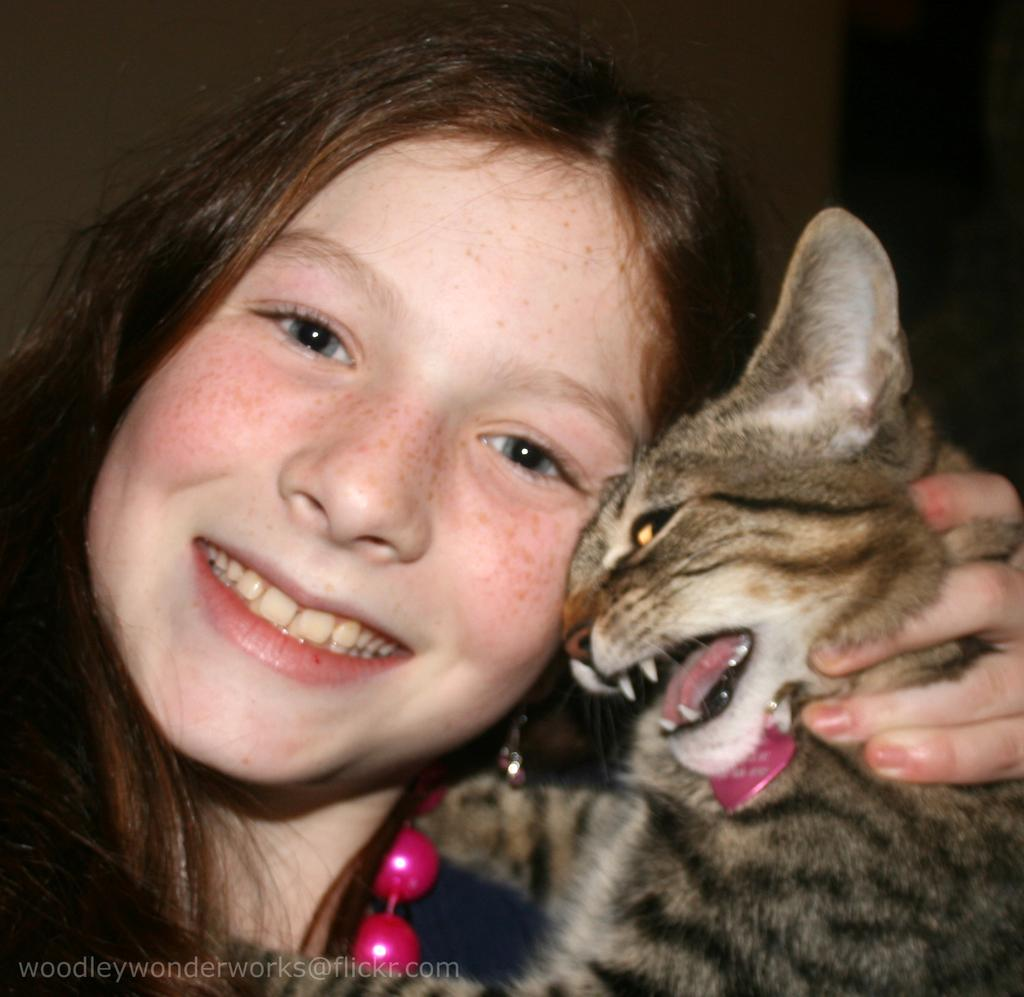Who is present in the image? There is a woman in the image. What is the woman holding? The woman is holding a cat. Where are the scissors located in the image? There are no scissors present in the image. What type of clover can be seen growing in the background of the image? There is no clover present in the image. 